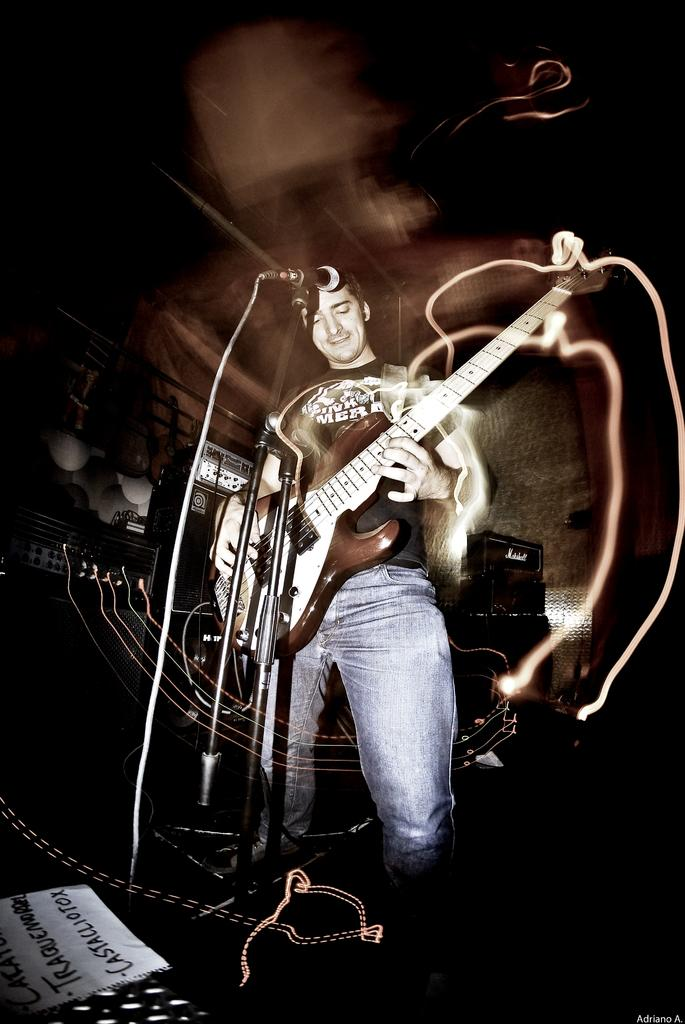What is the man in the image doing? The man is playing the guitar. How is the man positioned in the image? The man is standing in front of a microphone. What is the man holding in the image? The man is holding a guitar. What can be seen on the left side of the image? There is a paper on the left side of the image. Can you see an ant crawling on the man's tongue in the image? There is no ant or tongue visible in the image. What type of board is the man standing on in the image? The image does not show the man standing on a board; he is standing in front of a microphone. 